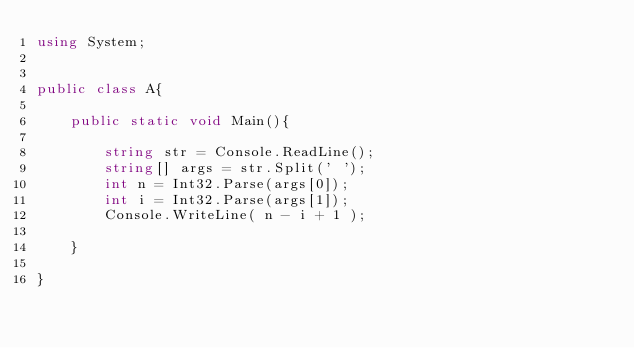Convert code to text. <code><loc_0><loc_0><loc_500><loc_500><_C#_>using System;


public class A{
	
	public static void Main(){
	
		string str = Console.ReadLine();
		string[] args = str.Split(' ');
		int n = Int32.Parse(args[0]);
		int i = Int32.Parse(args[1]);
		Console.WriteLine( n - i + 1 );
		
	}
	
}</code> 